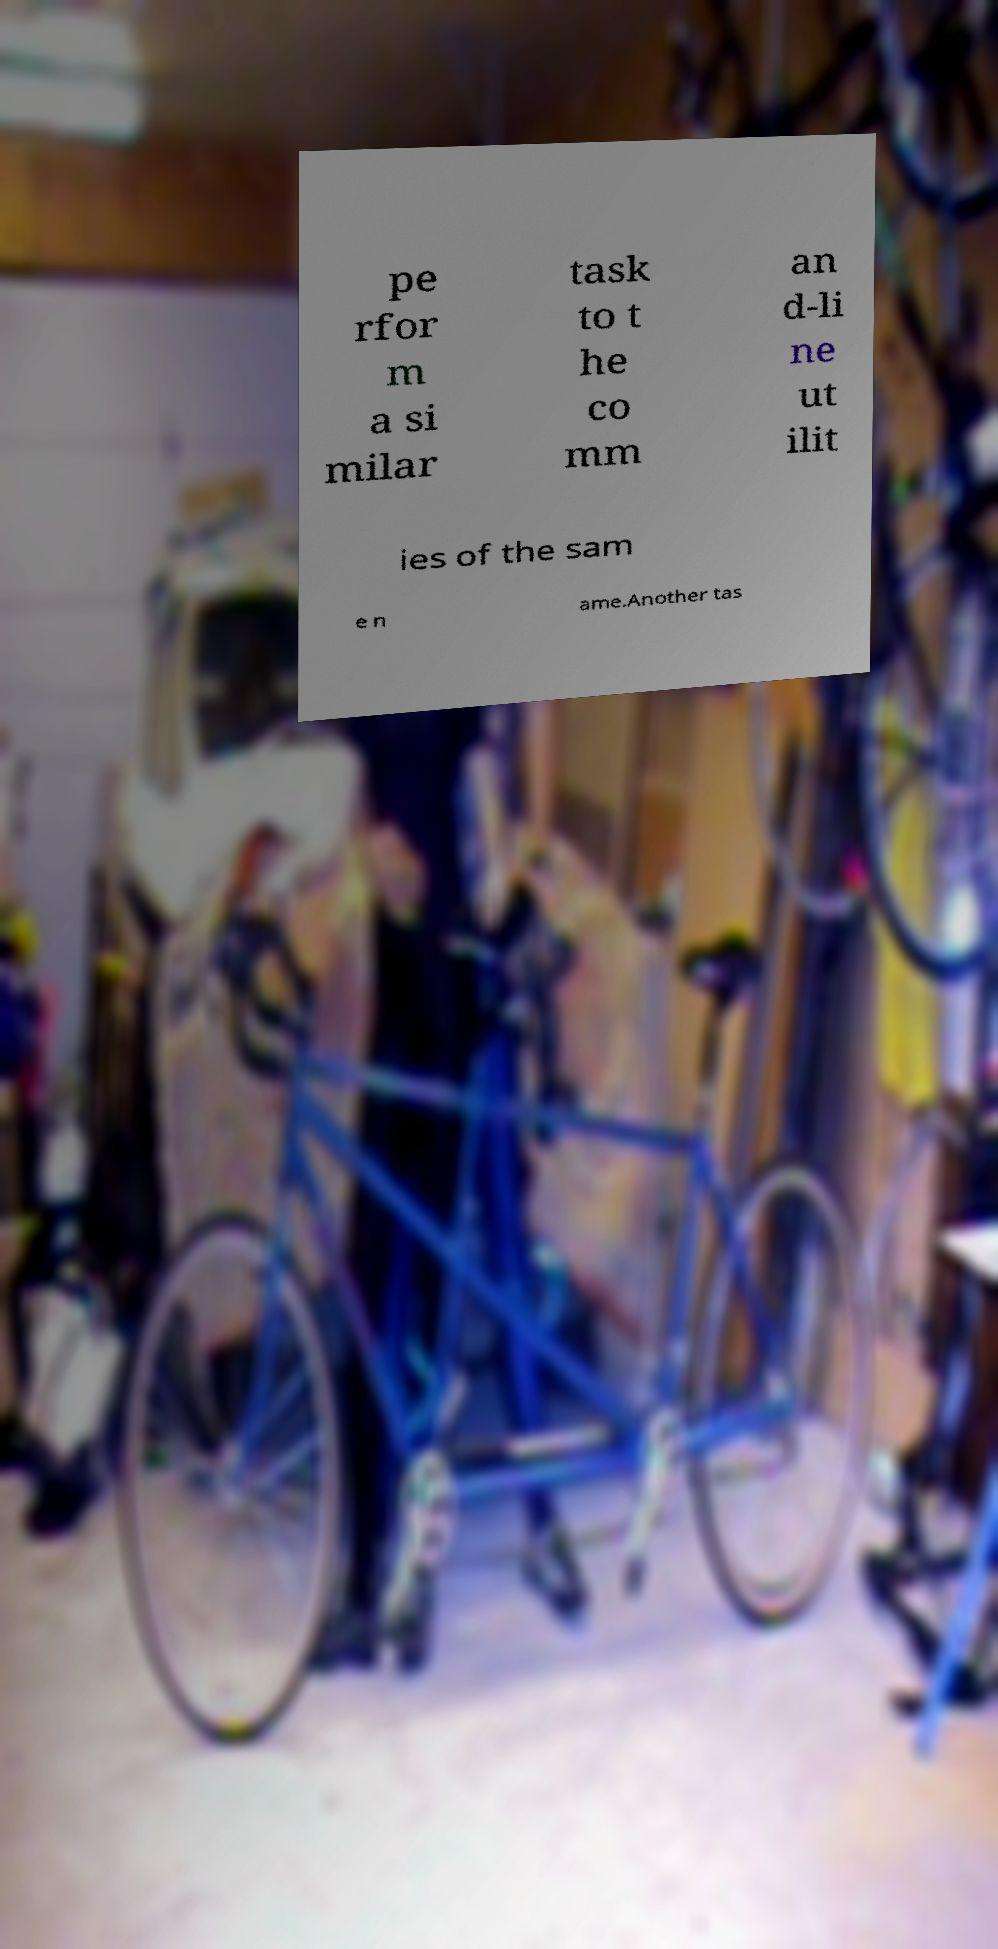Can you accurately transcribe the text from the provided image for me? pe rfor m a si milar task to t he co mm an d-li ne ut ilit ies of the sam e n ame.Another tas 